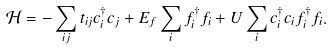<formula> <loc_0><loc_0><loc_500><loc_500>\mathcal { H } = - \sum _ { i j } t _ { i j } c ^ { \dagger } _ { i } c _ { j } + E _ { f } \sum _ { i } f ^ { \dagger } _ { i } f _ { i } + U \sum _ { i } c ^ { \dagger } _ { i } c _ { i } f ^ { \dagger } _ { i } f _ { i } .</formula> 